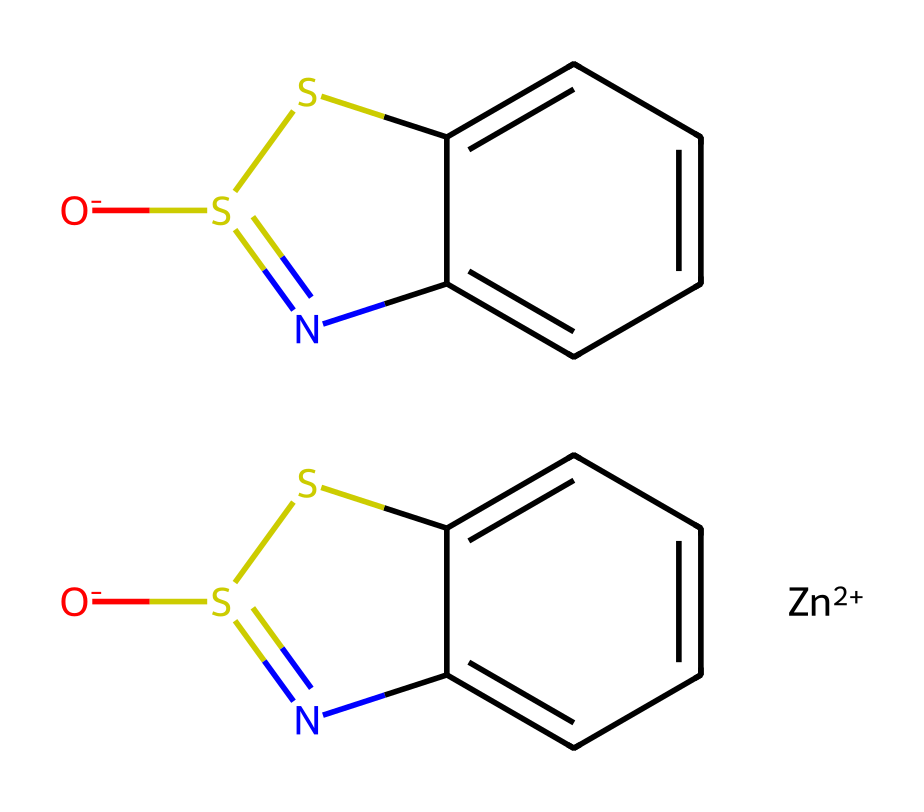What is the central metal in this chemical structure? The SMILES representation indicates the presence of [Zn+2], which designates zinc as the central metal ion in this organometallic compound.
Answer: zinc How many sulfur atoms are present in the structure? Looking at the SMILES representation, there are two instances of 'S', indicating the presence of two sulfur atoms in the chemical.
Answer: 2 What is the primary function of zinc pyrithione? Zinc pyrithione is known as an antifungal agent primarily used in shampoos.
Answer: antifungal Which functional groups are present in this molecule? The SMILES structure reveals the presence of thiazole rings and sulfur atoms, which are characteristic of the structure known as pyrithione.
Answer: thiazole and sulfur What is the oxidation state of zinc in this compound? From the notation [Zn+2], it is clear that zinc has an oxidation state of +2 in this organometallic compound.
Answer: +2 How many rings are present in the structure of zinc pyrithione? The arrangement of atoms in the SMILES suggests the presence of two fused ring systems, meaning there are two rings in total.
Answer: 2 